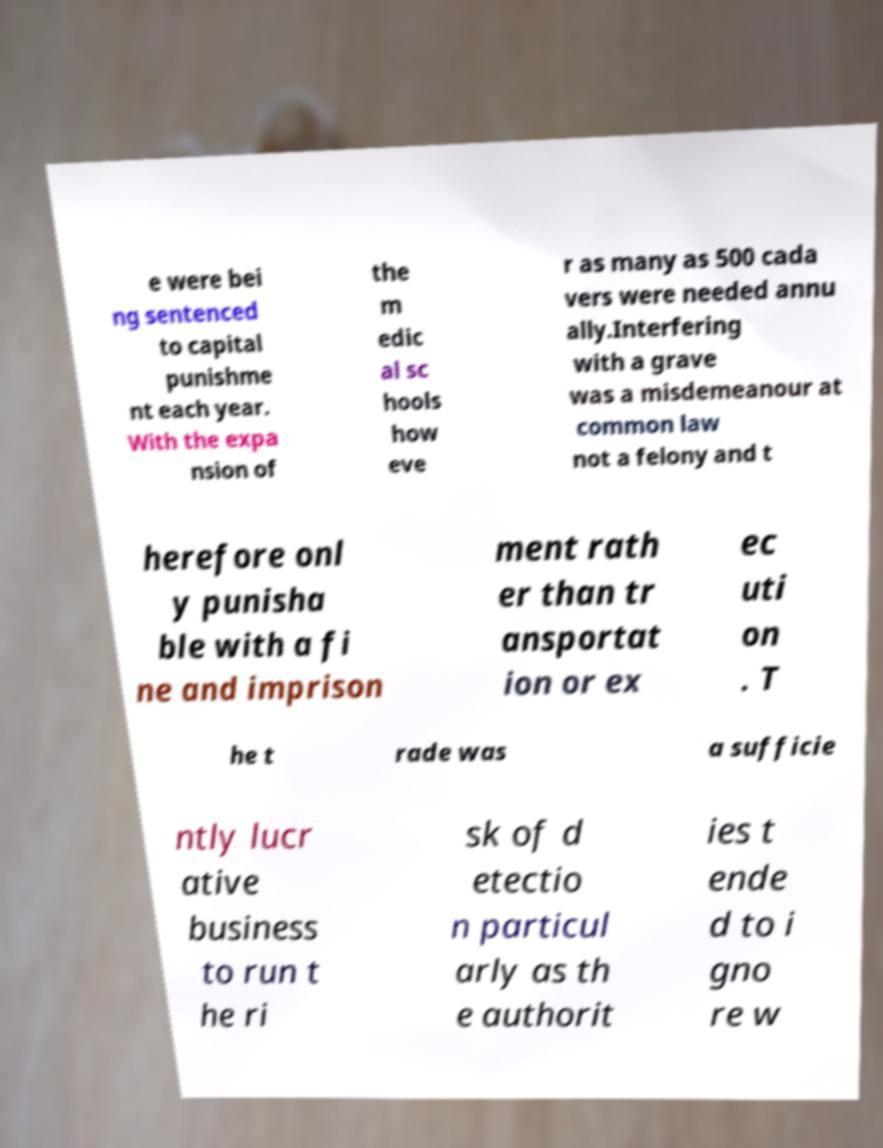Please identify and transcribe the text found in this image. e were bei ng sentenced to capital punishme nt each year. With the expa nsion of the m edic al sc hools how eve r as many as 500 cada vers were needed annu ally.Interfering with a grave was a misdemeanour at common law not a felony and t herefore onl y punisha ble with a fi ne and imprison ment rath er than tr ansportat ion or ex ec uti on . T he t rade was a sufficie ntly lucr ative business to run t he ri sk of d etectio n particul arly as th e authorit ies t ende d to i gno re w 